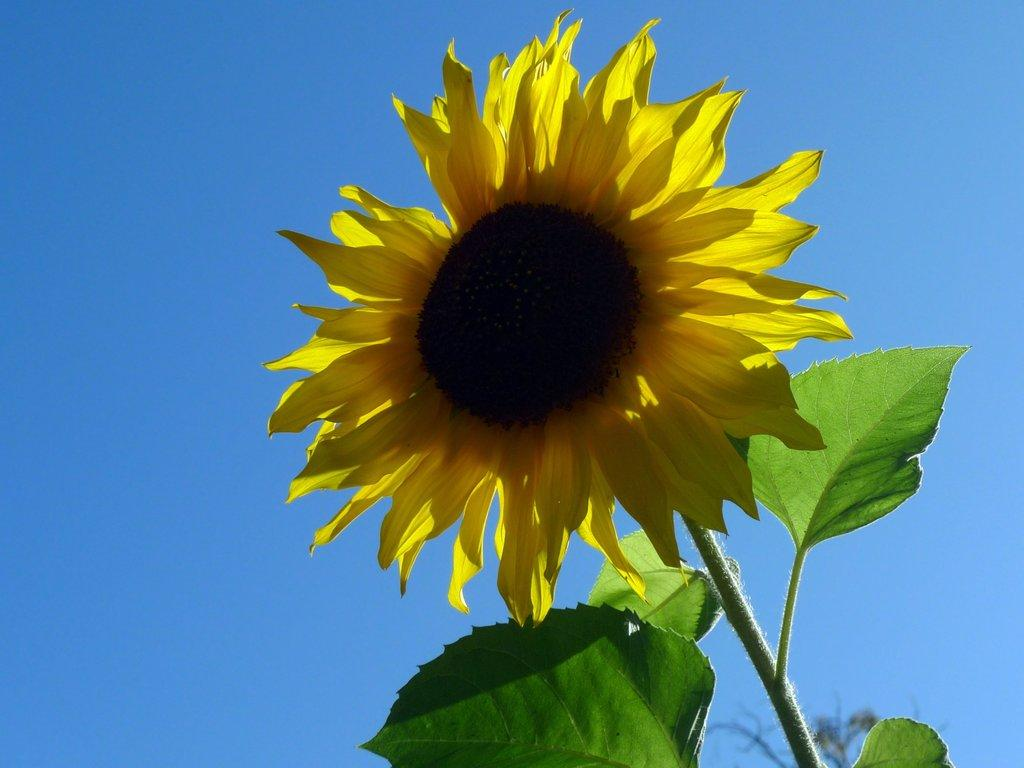What type of plant is in the picture? There is a sunflower in the picture. What parts of the sunflower can be seen? The sunflower has leaves. What can be seen in the background of the picture? The sky is visible in the background of the picture. What type of loaf is being used to stop the sunflower from growing in the picture? There is no loaf present in the image, and the sunflower is not growing in the picture. 